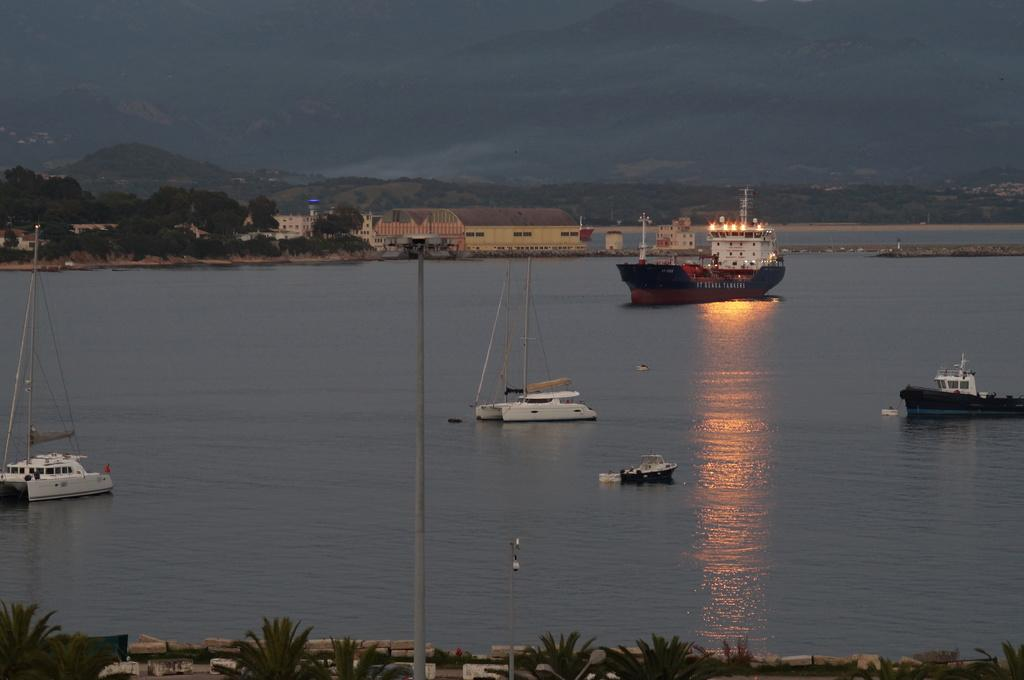What types of watercraft are in the image? There are boats and ships in the image. Where are the boats and ships located? They are on the surface of the water in the image. What other objects can be seen in the image? There are trees, buildings, and light poles visible in the image. How many legs does the ant have in the image? There are no ants present in the image. Is there a spy visible in the image? There is no indication of a spy in the image. 